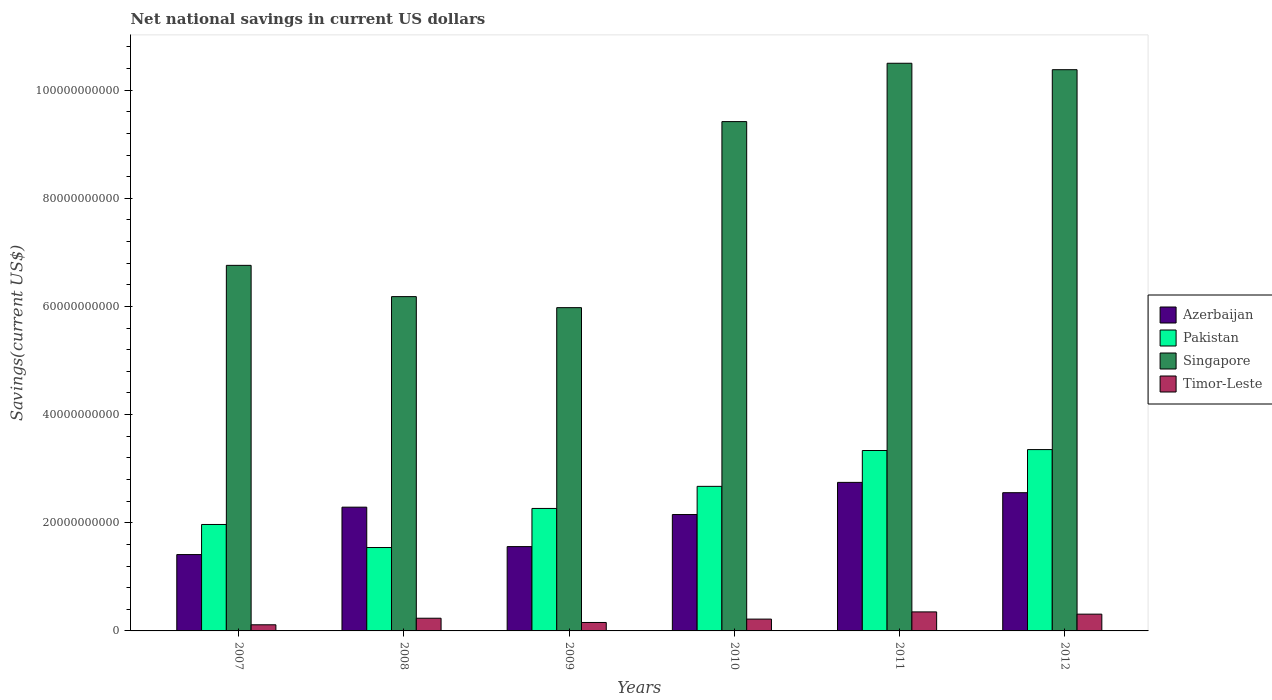Are the number of bars per tick equal to the number of legend labels?
Provide a succinct answer. Yes. Are the number of bars on each tick of the X-axis equal?
Your answer should be very brief. Yes. How many bars are there on the 1st tick from the right?
Your answer should be very brief. 4. In how many cases, is the number of bars for a given year not equal to the number of legend labels?
Your response must be concise. 0. What is the net national savings in Pakistan in 2009?
Your response must be concise. 2.26e+1. Across all years, what is the maximum net national savings in Pakistan?
Make the answer very short. 3.35e+1. Across all years, what is the minimum net national savings in Pakistan?
Offer a terse response. 1.54e+1. What is the total net national savings in Singapore in the graph?
Give a very brief answer. 4.92e+11. What is the difference between the net national savings in Singapore in 2009 and that in 2010?
Provide a short and direct response. -3.44e+1. What is the difference between the net national savings in Timor-Leste in 2011 and the net national savings in Azerbaijan in 2012?
Your answer should be very brief. -2.20e+1. What is the average net national savings in Pakistan per year?
Offer a very short reply. 2.52e+1. In the year 2011, what is the difference between the net national savings in Singapore and net national savings in Azerbaijan?
Provide a succinct answer. 7.75e+1. What is the ratio of the net national savings in Pakistan in 2009 to that in 2011?
Your answer should be very brief. 0.68. Is the difference between the net national savings in Singapore in 2009 and 2010 greater than the difference between the net national savings in Azerbaijan in 2009 and 2010?
Offer a very short reply. No. What is the difference between the highest and the second highest net national savings in Pakistan?
Ensure brevity in your answer.  1.69e+08. What is the difference between the highest and the lowest net national savings in Singapore?
Make the answer very short. 4.52e+1. In how many years, is the net national savings in Azerbaijan greater than the average net national savings in Azerbaijan taken over all years?
Provide a short and direct response. 4. Is the sum of the net national savings in Singapore in 2007 and 2010 greater than the maximum net national savings in Azerbaijan across all years?
Offer a terse response. Yes. Is it the case that in every year, the sum of the net national savings in Azerbaijan and net national savings in Singapore is greater than the sum of net national savings in Pakistan and net national savings in Timor-Leste?
Provide a short and direct response. Yes. What does the 2nd bar from the left in 2008 represents?
Make the answer very short. Pakistan. What does the 3rd bar from the right in 2012 represents?
Keep it short and to the point. Pakistan. Is it the case that in every year, the sum of the net national savings in Azerbaijan and net national savings in Pakistan is greater than the net national savings in Timor-Leste?
Make the answer very short. Yes. How many bars are there?
Offer a very short reply. 24. What is the difference between two consecutive major ticks on the Y-axis?
Offer a terse response. 2.00e+1. Are the values on the major ticks of Y-axis written in scientific E-notation?
Provide a succinct answer. No. Does the graph contain any zero values?
Ensure brevity in your answer.  No. How many legend labels are there?
Keep it short and to the point. 4. What is the title of the graph?
Ensure brevity in your answer.  Net national savings in current US dollars. What is the label or title of the X-axis?
Your answer should be compact. Years. What is the label or title of the Y-axis?
Keep it short and to the point. Savings(current US$). What is the Savings(current US$) in Azerbaijan in 2007?
Your answer should be very brief. 1.41e+1. What is the Savings(current US$) of Pakistan in 2007?
Give a very brief answer. 1.97e+1. What is the Savings(current US$) of Singapore in 2007?
Provide a succinct answer. 6.76e+1. What is the Savings(current US$) of Timor-Leste in 2007?
Your response must be concise. 1.13e+09. What is the Savings(current US$) in Azerbaijan in 2008?
Provide a short and direct response. 2.29e+1. What is the Savings(current US$) of Pakistan in 2008?
Your answer should be compact. 1.54e+1. What is the Savings(current US$) of Singapore in 2008?
Offer a very short reply. 6.18e+1. What is the Savings(current US$) in Timor-Leste in 2008?
Your response must be concise. 2.35e+09. What is the Savings(current US$) of Azerbaijan in 2009?
Provide a succinct answer. 1.56e+1. What is the Savings(current US$) of Pakistan in 2009?
Offer a very short reply. 2.26e+1. What is the Savings(current US$) in Singapore in 2009?
Your answer should be compact. 5.98e+1. What is the Savings(current US$) of Timor-Leste in 2009?
Make the answer very short. 1.56e+09. What is the Savings(current US$) of Azerbaijan in 2010?
Make the answer very short. 2.15e+1. What is the Savings(current US$) in Pakistan in 2010?
Your answer should be compact. 2.67e+1. What is the Savings(current US$) of Singapore in 2010?
Your answer should be compact. 9.42e+1. What is the Savings(current US$) of Timor-Leste in 2010?
Your response must be concise. 2.18e+09. What is the Savings(current US$) of Azerbaijan in 2011?
Your answer should be compact. 2.75e+1. What is the Savings(current US$) in Pakistan in 2011?
Give a very brief answer. 3.34e+1. What is the Savings(current US$) in Singapore in 2011?
Give a very brief answer. 1.05e+11. What is the Savings(current US$) of Timor-Leste in 2011?
Ensure brevity in your answer.  3.52e+09. What is the Savings(current US$) of Azerbaijan in 2012?
Offer a terse response. 2.56e+1. What is the Savings(current US$) of Pakistan in 2012?
Offer a very short reply. 3.35e+1. What is the Savings(current US$) of Singapore in 2012?
Offer a terse response. 1.04e+11. What is the Savings(current US$) of Timor-Leste in 2012?
Your response must be concise. 3.10e+09. Across all years, what is the maximum Savings(current US$) of Azerbaijan?
Your answer should be very brief. 2.75e+1. Across all years, what is the maximum Savings(current US$) in Pakistan?
Provide a short and direct response. 3.35e+1. Across all years, what is the maximum Savings(current US$) in Singapore?
Give a very brief answer. 1.05e+11. Across all years, what is the maximum Savings(current US$) in Timor-Leste?
Give a very brief answer. 3.52e+09. Across all years, what is the minimum Savings(current US$) in Azerbaijan?
Your answer should be compact. 1.41e+1. Across all years, what is the minimum Savings(current US$) in Pakistan?
Provide a succinct answer. 1.54e+1. Across all years, what is the minimum Savings(current US$) in Singapore?
Your response must be concise. 5.98e+1. Across all years, what is the minimum Savings(current US$) in Timor-Leste?
Give a very brief answer. 1.13e+09. What is the total Savings(current US$) in Azerbaijan in the graph?
Provide a succinct answer. 1.27e+11. What is the total Savings(current US$) of Pakistan in the graph?
Ensure brevity in your answer.  1.51e+11. What is the total Savings(current US$) of Singapore in the graph?
Provide a short and direct response. 4.92e+11. What is the total Savings(current US$) in Timor-Leste in the graph?
Keep it short and to the point. 1.38e+1. What is the difference between the Savings(current US$) of Azerbaijan in 2007 and that in 2008?
Your response must be concise. -8.77e+09. What is the difference between the Savings(current US$) in Pakistan in 2007 and that in 2008?
Make the answer very short. 4.26e+09. What is the difference between the Savings(current US$) in Singapore in 2007 and that in 2008?
Provide a short and direct response. 5.78e+09. What is the difference between the Savings(current US$) in Timor-Leste in 2007 and that in 2008?
Offer a terse response. -1.21e+09. What is the difference between the Savings(current US$) of Azerbaijan in 2007 and that in 2009?
Ensure brevity in your answer.  -1.47e+09. What is the difference between the Savings(current US$) of Pakistan in 2007 and that in 2009?
Your answer should be very brief. -2.97e+09. What is the difference between the Savings(current US$) of Singapore in 2007 and that in 2009?
Give a very brief answer. 7.82e+09. What is the difference between the Savings(current US$) of Timor-Leste in 2007 and that in 2009?
Your response must be concise. -4.27e+08. What is the difference between the Savings(current US$) in Azerbaijan in 2007 and that in 2010?
Make the answer very short. -7.40e+09. What is the difference between the Savings(current US$) in Pakistan in 2007 and that in 2010?
Keep it short and to the point. -7.05e+09. What is the difference between the Savings(current US$) in Singapore in 2007 and that in 2010?
Give a very brief answer. -2.66e+1. What is the difference between the Savings(current US$) in Timor-Leste in 2007 and that in 2010?
Your response must be concise. -1.05e+09. What is the difference between the Savings(current US$) of Azerbaijan in 2007 and that in 2011?
Offer a terse response. -1.33e+1. What is the difference between the Savings(current US$) of Pakistan in 2007 and that in 2011?
Your answer should be very brief. -1.37e+1. What is the difference between the Savings(current US$) in Singapore in 2007 and that in 2011?
Offer a very short reply. -3.74e+1. What is the difference between the Savings(current US$) in Timor-Leste in 2007 and that in 2011?
Provide a short and direct response. -2.38e+09. What is the difference between the Savings(current US$) in Azerbaijan in 2007 and that in 2012?
Make the answer very short. -1.14e+1. What is the difference between the Savings(current US$) of Pakistan in 2007 and that in 2012?
Your answer should be compact. -1.38e+1. What is the difference between the Savings(current US$) of Singapore in 2007 and that in 2012?
Ensure brevity in your answer.  -3.62e+1. What is the difference between the Savings(current US$) of Timor-Leste in 2007 and that in 2012?
Provide a succinct answer. -1.97e+09. What is the difference between the Savings(current US$) of Azerbaijan in 2008 and that in 2009?
Provide a succinct answer. 7.29e+09. What is the difference between the Savings(current US$) of Pakistan in 2008 and that in 2009?
Provide a short and direct response. -7.23e+09. What is the difference between the Savings(current US$) in Singapore in 2008 and that in 2009?
Provide a succinct answer. 2.04e+09. What is the difference between the Savings(current US$) in Timor-Leste in 2008 and that in 2009?
Your answer should be very brief. 7.85e+08. What is the difference between the Savings(current US$) in Azerbaijan in 2008 and that in 2010?
Keep it short and to the point. 1.36e+09. What is the difference between the Savings(current US$) in Pakistan in 2008 and that in 2010?
Provide a succinct answer. -1.13e+1. What is the difference between the Savings(current US$) of Singapore in 2008 and that in 2010?
Your answer should be very brief. -3.24e+1. What is the difference between the Savings(current US$) in Timor-Leste in 2008 and that in 2010?
Offer a terse response. 1.62e+08. What is the difference between the Savings(current US$) in Azerbaijan in 2008 and that in 2011?
Your answer should be very brief. -4.58e+09. What is the difference between the Savings(current US$) of Pakistan in 2008 and that in 2011?
Offer a very short reply. -1.79e+1. What is the difference between the Savings(current US$) of Singapore in 2008 and that in 2011?
Your answer should be very brief. -4.31e+1. What is the difference between the Savings(current US$) of Timor-Leste in 2008 and that in 2011?
Offer a very short reply. -1.17e+09. What is the difference between the Savings(current US$) of Azerbaijan in 2008 and that in 2012?
Offer a terse response. -2.68e+09. What is the difference between the Savings(current US$) of Pakistan in 2008 and that in 2012?
Provide a succinct answer. -1.81e+1. What is the difference between the Savings(current US$) of Singapore in 2008 and that in 2012?
Ensure brevity in your answer.  -4.20e+1. What is the difference between the Savings(current US$) in Timor-Leste in 2008 and that in 2012?
Provide a succinct answer. -7.54e+08. What is the difference between the Savings(current US$) of Azerbaijan in 2009 and that in 2010?
Your answer should be very brief. -5.93e+09. What is the difference between the Savings(current US$) in Pakistan in 2009 and that in 2010?
Offer a very short reply. -4.08e+09. What is the difference between the Savings(current US$) of Singapore in 2009 and that in 2010?
Offer a terse response. -3.44e+1. What is the difference between the Savings(current US$) in Timor-Leste in 2009 and that in 2010?
Keep it short and to the point. -6.23e+08. What is the difference between the Savings(current US$) in Azerbaijan in 2009 and that in 2011?
Your answer should be very brief. -1.19e+1. What is the difference between the Savings(current US$) of Pakistan in 2009 and that in 2011?
Give a very brief answer. -1.07e+1. What is the difference between the Savings(current US$) of Singapore in 2009 and that in 2011?
Ensure brevity in your answer.  -4.52e+1. What is the difference between the Savings(current US$) in Timor-Leste in 2009 and that in 2011?
Provide a short and direct response. -1.96e+09. What is the difference between the Savings(current US$) of Azerbaijan in 2009 and that in 2012?
Make the answer very short. -9.97e+09. What is the difference between the Savings(current US$) in Pakistan in 2009 and that in 2012?
Ensure brevity in your answer.  -1.09e+1. What is the difference between the Savings(current US$) in Singapore in 2009 and that in 2012?
Give a very brief answer. -4.40e+1. What is the difference between the Savings(current US$) of Timor-Leste in 2009 and that in 2012?
Keep it short and to the point. -1.54e+09. What is the difference between the Savings(current US$) of Azerbaijan in 2010 and that in 2011?
Offer a terse response. -5.95e+09. What is the difference between the Savings(current US$) of Pakistan in 2010 and that in 2011?
Offer a terse response. -6.63e+09. What is the difference between the Savings(current US$) of Singapore in 2010 and that in 2011?
Offer a terse response. -1.08e+1. What is the difference between the Savings(current US$) in Timor-Leste in 2010 and that in 2011?
Your answer should be very brief. -1.33e+09. What is the difference between the Savings(current US$) in Azerbaijan in 2010 and that in 2012?
Your answer should be compact. -4.04e+09. What is the difference between the Savings(current US$) in Pakistan in 2010 and that in 2012?
Give a very brief answer. -6.80e+09. What is the difference between the Savings(current US$) in Singapore in 2010 and that in 2012?
Give a very brief answer. -9.60e+09. What is the difference between the Savings(current US$) in Timor-Leste in 2010 and that in 2012?
Provide a short and direct response. -9.16e+08. What is the difference between the Savings(current US$) in Azerbaijan in 2011 and that in 2012?
Your answer should be very brief. 1.91e+09. What is the difference between the Savings(current US$) in Pakistan in 2011 and that in 2012?
Offer a very short reply. -1.69e+08. What is the difference between the Savings(current US$) in Singapore in 2011 and that in 2012?
Provide a succinct answer. 1.19e+09. What is the difference between the Savings(current US$) of Timor-Leste in 2011 and that in 2012?
Your answer should be compact. 4.17e+08. What is the difference between the Savings(current US$) of Azerbaijan in 2007 and the Savings(current US$) of Pakistan in 2008?
Ensure brevity in your answer.  -1.30e+09. What is the difference between the Savings(current US$) of Azerbaijan in 2007 and the Savings(current US$) of Singapore in 2008?
Your answer should be compact. -4.77e+1. What is the difference between the Savings(current US$) in Azerbaijan in 2007 and the Savings(current US$) in Timor-Leste in 2008?
Provide a succinct answer. 1.18e+1. What is the difference between the Savings(current US$) of Pakistan in 2007 and the Savings(current US$) of Singapore in 2008?
Make the answer very short. -4.21e+1. What is the difference between the Savings(current US$) in Pakistan in 2007 and the Savings(current US$) in Timor-Leste in 2008?
Provide a short and direct response. 1.73e+1. What is the difference between the Savings(current US$) of Singapore in 2007 and the Savings(current US$) of Timor-Leste in 2008?
Ensure brevity in your answer.  6.53e+1. What is the difference between the Savings(current US$) of Azerbaijan in 2007 and the Savings(current US$) of Pakistan in 2009?
Your response must be concise. -8.53e+09. What is the difference between the Savings(current US$) of Azerbaijan in 2007 and the Savings(current US$) of Singapore in 2009?
Keep it short and to the point. -4.57e+1. What is the difference between the Savings(current US$) of Azerbaijan in 2007 and the Savings(current US$) of Timor-Leste in 2009?
Offer a terse response. 1.26e+1. What is the difference between the Savings(current US$) in Pakistan in 2007 and the Savings(current US$) in Singapore in 2009?
Give a very brief answer. -4.01e+1. What is the difference between the Savings(current US$) in Pakistan in 2007 and the Savings(current US$) in Timor-Leste in 2009?
Provide a short and direct response. 1.81e+1. What is the difference between the Savings(current US$) in Singapore in 2007 and the Savings(current US$) in Timor-Leste in 2009?
Provide a short and direct response. 6.60e+1. What is the difference between the Savings(current US$) of Azerbaijan in 2007 and the Savings(current US$) of Pakistan in 2010?
Provide a short and direct response. -1.26e+1. What is the difference between the Savings(current US$) in Azerbaijan in 2007 and the Savings(current US$) in Singapore in 2010?
Make the answer very short. -8.01e+1. What is the difference between the Savings(current US$) in Azerbaijan in 2007 and the Savings(current US$) in Timor-Leste in 2010?
Your response must be concise. 1.19e+1. What is the difference between the Savings(current US$) in Pakistan in 2007 and the Savings(current US$) in Singapore in 2010?
Provide a succinct answer. -7.45e+1. What is the difference between the Savings(current US$) of Pakistan in 2007 and the Savings(current US$) of Timor-Leste in 2010?
Offer a very short reply. 1.75e+1. What is the difference between the Savings(current US$) in Singapore in 2007 and the Savings(current US$) in Timor-Leste in 2010?
Keep it short and to the point. 6.54e+1. What is the difference between the Savings(current US$) of Azerbaijan in 2007 and the Savings(current US$) of Pakistan in 2011?
Your response must be concise. -1.92e+1. What is the difference between the Savings(current US$) of Azerbaijan in 2007 and the Savings(current US$) of Singapore in 2011?
Offer a terse response. -9.08e+1. What is the difference between the Savings(current US$) in Azerbaijan in 2007 and the Savings(current US$) in Timor-Leste in 2011?
Offer a very short reply. 1.06e+1. What is the difference between the Savings(current US$) in Pakistan in 2007 and the Savings(current US$) in Singapore in 2011?
Your answer should be very brief. -8.53e+1. What is the difference between the Savings(current US$) of Pakistan in 2007 and the Savings(current US$) of Timor-Leste in 2011?
Keep it short and to the point. 1.62e+1. What is the difference between the Savings(current US$) in Singapore in 2007 and the Savings(current US$) in Timor-Leste in 2011?
Ensure brevity in your answer.  6.41e+1. What is the difference between the Savings(current US$) of Azerbaijan in 2007 and the Savings(current US$) of Pakistan in 2012?
Give a very brief answer. -1.94e+1. What is the difference between the Savings(current US$) in Azerbaijan in 2007 and the Savings(current US$) in Singapore in 2012?
Offer a terse response. -8.97e+1. What is the difference between the Savings(current US$) in Azerbaijan in 2007 and the Savings(current US$) in Timor-Leste in 2012?
Keep it short and to the point. 1.10e+1. What is the difference between the Savings(current US$) in Pakistan in 2007 and the Savings(current US$) in Singapore in 2012?
Your answer should be very brief. -8.41e+1. What is the difference between the Savings(current US$) of Pakistan in 2007 and the Savings(current US$) of Timor-Leste in 2012?
Ensure brevity in your answer.  1.66e+1. What is the difference between the Savings(current US$) in Singapore in 2007 and the Savings(current US$) in Timor-Leste in 2012?
Provide a short and direct response. 6.45e+1. What is the difference between the Savings(current US$) of Azerbaijan in 2008 and the Savings(current US$) of Pakistan in 2009?
Ensure brevity in your answer.  2.37e+08. What is the difference between the Savings(current US$) of Azerbaijan in 2008 and the Savings(current US$) of Singapore in 2009?
Provide a succinct answer. -3.69e+1. What is the difference between the Savings(current US$) of Azerbaijan in 2008 and the Savings(current US$) of Timor-Leste in 2009?
Keep it short and to the point. 2.13e+1. What is the difference between the Savings(current US$) in Pakistan in 2008 and the Savings(current US$) in Singapore in 2009?
Provide a short and direct response. -4.44e+1. What is the difference between the Savings(current US$) of Pakistan in 2008 and the Savings(current US$) of Timor-Leste in 2009?
Your answer should be very brief. 1.39e+1. What is the difference between the Savings(current US$) in Singapore in 2008 and the Savings(current US$) in Timor-Leste in 2009?
Keep it short and to the point. 6.03e+1. What is the difference between the Savings(current US$) of Azerbaijan in 2008 and the Savings(current US$) of Pakistan in 2010?
Your answer should be compact. -3.85e+09. What is the difference between the Savings(current US$) of Azerbaijan in 2008 and the Savings(current US$) of Singapore in 2010?
Make the answer very short. -7.13e+1. What is the difference between the Savings(current US$) in Azerbaijan in 2008 and the Savings(current US$) in Timor-Leste in 2010?
Your answer should be very brief. 2.07e+1. What is the difference between the Savings(current US$) in Pakistan in 2008 and the Savings(current US$) in Singapore in 2010?
Offer a terse response. -7.88e+1. What is the difference between the Savings(current US$) in Pakistan in 2008 and the Savings(current US$) in Timor-Leste in 2010?
Your answer should be compact. 1.32e+1. What is the difference between the Savings(current US$) of Singapore in 2008 and the Savings(current US$) of Timor-Leste in 2010?
Your answer should be very brief. 5.96e+1. What is the difference between the Savings(current US$) of Azerbaijan in 2008 and the Savings(current US$) of Pakistan in 2011?
Offer a very short reply. -1.05e+1. What is the difference between the Savings(current US$) of Azerbaijan in 2008 and the Savings(current US$) of Singapore in 2011?
Provide a succinct answer. -8.21e+1. What is the difference between the Savings(current US$) in Azerbaijan in 2008 and the Savings(current US$) in Timor-Leste in 2011?
Ensure brevity in your answer.  1.94e+1. What is the difference between the Savings(current US$) in Pakistan in 2008 and the Savings(current US$) in Singapore in 2011?
Your answer should be very brief. -8.95e+1. What is the difference between the Savings(current US$) in Pakistan in 2008 and the Savings(current US$) in Timor-Leste in 2011?
Provide a short and direct response. 1.19e+1. What is the difference between the Savings(current US$) of Singapore in 2008 and the Savings(current US$) of Timor-Leste in 2011?
Keep it short and to the point. 5.83e+1. What is the difference between the Savings(current US$) in Azerbaijan in 2008 and the Savings(current US$) in Pakistan in 2012?
Provide a succinct answer. -1.06e+1. What is the difference between the Savings(current US$) of Azerbaijan in 2008 and the Savings(current US$) of Singapore in 2012?
Offer a terse response. -8.09e+1. What is the difference between the Savings(current US$) of Azerbaijan in 2008 and the Savings(current US$) of Timor-Leste in 2012?
Your answer should be very brief. 1.98e+1. What is the difference between the Savings(current US$) of Pakistan in 2008 and the Savings(current US$) of Singapore in 2012?
Ensure brevity in your answer.  -8.84e+1. What is the difference between the Savings(current US$) in Pakistan in 2008 and the Savings(current US$) in Timor-Leste in 2012?
Your response must be concise. 1.23e+1. What is the difference between the Savings(current US$) in Singapore in 2008 and the Savings(current US$) in Timor-Leste in 2012?
Make the answer very short. 5.87e+1. What is the difference between the Savings(current US$) in Azerbaijan in 2009 and the Savings(current US$) in Pakistan in 2010?
Ensure brevity in your answer.  -1.11e+1. What is the difference between the Savings(current US$) of Azerbaijan in 2009 and the Savings(current US$) of Singapore in 2010?
Provide a succinct answer. -7.86e+1. What is the difference between the Savings(current US$) of Azerbaijan in 2009 and the Savings(current US$) of Timor-Leste in 2010?
Keep it short and to the point. 1.34e+1. What is the difference between the Savings(current US$) of Pakistan in 2009 and the Savings(current US$) of Singapore in 2010?
Keep it short and to the point. -7.15e+1. What is the difference between the Savings(current US$) in Pakistan in 2009 and the Savings(current US$) in Timor-Leste in 2010?
Your answer should be very brief. 2.05e+1. What is the difference between the Savings(current US$) in Singapore in 2009 and the Savings(current US$) in Timor-Leste in 2010?
Keep it short and to the point. 5.76e+1. What is the difference between the Savings(current US$) in Azerbaijan in 2009 and the Savings(current US$) in Pakistan in 2011?
Make the answer very short. -1.78e+1. What is the difference between the Savings(current US$) of Azerbaijan in 2009 and the Savings(current US$) of Singapore in 2011?
Provide a short and direct response. -8.94e+1. What is the difference between the Savings(current US$) of Azerbaijan in 2009 and the Savings(current US$) of Timor-Leste in 2011?
Offer a very short reply. 1.21e+1. What is the difference between the Savings(current US$) of Pakistan in 2009 and the Savings(current US$) of Singapore in 2011?
Ensure brevity in your answer.  -8.23e+1. What is the difference between the Savings(current US$) in Pakistan in 2009 and the Savings(current US$) in Timor-Leste in 2011?
Ensure brevity in your answer.  1.91e+1. What is the difference between the Savings(current US$) in Singapore in 2009 and the Savings(current US$) in Timor-Leste in 2011?
Make the answer very short. 5.63e+1. What is the difference between the Savings(current US$) in Azerbaijan in 2009 and the Savings(current US$) in Pakistan in 2012?
Offer a very short reply. -1.79e+1. What is the difference between the Savings(current US$) of Azerbaijan in 2009 and the Savings(current US$) of Singapore in 2012?
Your answer should be very brief. -8.82e+1. What is the difference between the Savings(current US$) of Azerbaijan in 2009 and the Savings(current US$) of Timor-Leste in 2012?
Make the answer very short. 1.25e+1. What is the difference between the Savings(current US$) in Pakistan in 2009 and the Savings(current US$) in Singapore in 2012?
Make the answer very short. -8.11e+1. What is the difference between the Savings(current US$) of Pakistan in 2009 and the Savings(current US$) of Timor-Leste in 2012?
Offer a terse response. 1.95e+1. What is the difference between the Savings(current US$) of Singapore in 2009 and the Savings(current US$) of Timor-Leste in 2012?
Your answer should be very brief. 5.67e+1. What is the difference between the Savings(current US$) in Azerbaijan in 2010 and the Savings(current US$) in Pakistan in 2011?
Your answer should be compact. -1.18e+1. What is the difference between the Savings(current US$) of Azerbaijan in 2010 and the Savings(current US$) of Singapore in 2011?
Your response must be concise. -8.34e+1. What is the difference between the Savings(current US$) in Azerbaijan in 2010 and the Savings(current US$) in Timor-Leste in 2011?
Provide a short and direct response. 1.80e+1. What is the difference between the Savings(current US$) of Pakistan in 2010 and the Savings(current US$) of Singapore in 2011?
Ensure brevity in your answer.  -7.82e+1. What is the difference between the Savings(current US$) of Pakistan in 2010 and the Savings(current US$) of Timor-Leste in 2011?
Your response must be concise. 2.32e+1. What is the difference between the Savings(current US$) of Singapore in 2010 and the Savings(current US$) of Timor-Leste in 2011?
Give a very brief answer. 9.07e+1. What is the difference between the Savings(current US$) of Azerbaijan in 2010 and the Savings(current US$) of Pakistan in 2012?
Provide a succinct answer. -1.20e+1. What is the difference between the Savings(current US$) of Azerbaijan in 2010 and the Savings(current US$) of Singapore in 2012?
Your answer should be compact. -8.23e+1. What is the difference between the Savings(current US$) in Azerbaijan in 2010 and the Savings(current US$) in Timor-Leste in 2012?
Your answer should be compact. 1.84e+1. What is the difference between the Savings(current US$) of Pakistan in 2010 and the Savings(current US$) of Singapore in 2012?
Provide a succinct answer. -7.70e+1. What is the difference between the Savings(current US$) of Pakistan in 2010 and the Savings(current US$) of Timor-Leste in 2012?
Your answer should be compact. 2.36e+1. What is the difference between the Savings(current US$) in Singapore in 2010 and the Savings(current US$) in Timor-Leste in 2012?
Provide a succinct answer. 9.11e+1. What is the difference between the Savings(current US$) of Azerbaijan in 2011 and the Savings(current US$) of Pakistan in 2012?
Provide a short and direct response. -6.06e+09. What is the difference between the Savings(current US$) of Azerbaijan in 2011 and the Savings(current US$) of Singapore in 2012?
Your answer should be compact. -7.63e+1. What is the difference between the Savings(current US$) in Azerbaijan in 2011 and the Savings(current US$) in Timor-Leste in 2012?
Keep it short and to the point. 2.44e+1. What is the difference between the Savings(current US$) of Pakistan in 2011 and the Savings(current US$) of Singapore in 2012?
Ensure brevity in your answer.  -7.04e+1. What is the difference between the Savings(current US$) of Pakistan in 2011 and the Savings(current US$) of Timor-Leste in 2012?
Your answer should be compact. 3.03e+1. What is the difference between the Savings(current US$) in Singapore in 2011 and the Savings(current US$) in Timor-Leste in 2012?
Offer a very short reply. 1.02e+11. What is the average Savings(current US$) in Azerbaijan per year?
Your response must be concise. 2.12e+1. What is the average Savings(current US$) in Pakistan per year?
Your answer should be compact. 2.52e+1. What is the average Savings(current US$) in Singapore per year?
Your answer should be compact. 8.20e+1. What is the average Savings(current US$) of Timor-Leste per year?
Offer a very short reply. 2.31e+09. In the year 2007, what is the difference between the Savings(current US$) in Azerbaijan and Savings(current US$) in Pakistan?
Offer a terse response. -5.56e+09. In the year 2007, what is the difference between the Savings(current US$) in Azerbaijan and Savings(current US$) in Singapore?
Provide a succinct answer. -5.35e+1. In the year 2007, what is the difference between the Savings(current US$) in Azerbaijan and Savings(current US$) in Timor-Leste?
Your response must be concise. 1.30e+1. In the year 2007, what is the difference between the Savings(current US$) of Pakistan and Savings(current US$) of Singapore?
Your response must be concise. -4.79e+1. In the year 2007, what is the difference between the Savings(current US$) in Pakistan and Savings(current US$) in Timor-Leste?
Give a very brief answer. 1.85e+1. In the year 2007, what is the difference between the Savings(current US$) of Singapore and Savings(current US$) of Timor-Leste?
Your answer should be very brief. 6.65e+1. In the year 2008, what is the difference between the Savings(current US$) of Azerbaijan and Savings(current US$) of Pakistan?
Ensure brevity in your answer.  7.46e+09. In the year 2008, what is the difference between the Savings(current US$) of Azerbaijan and Savings(current US$) of Singapore?
Ensure brevity in your answer.  -3.89e+1. In the year 2008, what is the difference between the Savings(current US$) in Azerbaijan and Savings(current US$) in Timor-Leste?
Give a very brief answer. 2.05e+1. In the year 2008, what is the difference between the Savings(current US$) of Pakistan and Savings(current US$) of Singapore?
Your answer should be compact. -4.64e+1. In the year 2008, what is the difference between the Savings(current US$) in Pakistan and Savings(current US$) in Timor-Leste?
Give a very brief answer. 1.31e+1. In the year 2008, what is the difference between the Savings(current US$) in Singapore and Savings(current US$) in Timor-Leste?
Your answer should be compact. 5.95e+1. In the year 2009, what is the difference between the Savings(current US$) of Azerbaijan and Savings(current US$) of Pakistan?
Offer a very short reply. -7.06e+09. In the year 2009, what is the difference between the Savings(current US$) of Azerbaijan and Savings(current US$) of Singapore?
Provide a short and direct response. -4.42e+1. In the year 2009, what is the difference between the Savings(current US$) in Azerbaijan and Savings(current US$) in Timor-Leste?
Your answer should be compact. 1.40e+1. In the year 2009, what is the difference between the Savings(current US$) in Pakistan and Savings(current US$) in Singapore?
Offer a very short reply. -3.71e+1. In the year 2009, what is the difference between the Savings(current US$) of Pakistan and Savings(current US$) of Timor-Leste?
Give a very brief answer. 2.11e+1. In the year 2009, what is the difference between the Savings(current US$) of Singapore and Savings(current US$) of Timor-Leste?
Provide a short and direct response. 5.82e+1. In the year 2010, what is the difference between the Savings(current US$) in Azerbaijan and Savings(current US$) in Pakistan?
Your answer should be very brief. -5.21e+09. In the year 2010, what is the difference between the Savings(current US$) in Azerbaijan and Savings(current US$) in Singapore?
Ensure brevity in your answer.  -7.27e+1. In the year 2010, what is the difference between the Savings(current US$) of Azerbaijan and Savings(current US$) of Timor-Leste?
Ensure brevity in your answer.  1.93e+1. In the year 2010, what is the difference between the Savings(current US$) of Pakistan and Savings(current US$) of Singapore?
Offer a terse response. -6.74e+1. In the year 2010, what is the difference between the Savings(current US$) in Pakistan and Savings(current US$) in Timor-Leste?
Offer a terse response. 2.45e+1. In the year 2010, what is the difference between the Savings(current US$) of Singapore and Savings(current US$) of Timor-Leste?
Your answer should be compact. 9.20e+1. In the year 2011, what is the difference between the Savings(current US$) of Azerbaijan and Savings(current US$) of Pakistan?
Your answer should be compact. -5.89e+09. In the year 2011, what is the difference between the Savings(current US$) in Azerbaijan and Savings(current US$) in Singapore?
Your response must be concise. -7.75e+1. In the year 2011, what is the difference between the Savings(current US$) of Azerbaijan and Savings(current US$) of Timor-Leste?
Your answer should be very brief. 2.39e+1. In the year 2011, what is the difference between the Savings(current US$) of Pakistan and Savings(current US$) of Singapore?
Offer a terse response. -7.16e+1. In the year 2011, what is the difference between the Savings(current US$) in Pakistan and Savings(current US$) in Timor-Leste?
Your response must be concise. 2.98e+1. In the year 2011, what is the difference between the Savings(current US$) in Singapore and Savings(current US$) in Timor-Leste?
Give a very brief answer. 1.01e+11. In the year 2012, what is the difference between the Savings(current US$) in Azerbaijan and Savings(current US$) in Pakistan?
Your response must be concise. -7.97e+09. In the year 2012, what is the difference between the Savings(current US$) of Azerbaijan and Savings(current US$) of Singapore?
Offer a terse response. -7.82e+1. In the year 2012, what is the difference between the Savings(current US$) in Azerbaijan and Savings(current US$) in Timor-Leste?
Make the answer very short. 2.25e+1. In the year 2012, what is the difference between the Savings(current US$) in Pakistan and Savings(current US$) in Singapore?
Offer a very short reply. -7.02e+1. In the year 2012, what is the difference between the Savings(current US$) in Pakistan and Savings(current US$) in Timor-Leste?
Make the answer very short. 3.04e+1. In the year 2012, what is the difference between the Savings(current US$) of Singapore and Savings(current US$) of Timor-Leste?
Give a very brief answer. 1.01e+11. What is the ratio of the Savings(current US$) in Azerbaijan in 2007 to that in 2008?
Your answer should be very brief. 0.62. What is the ratio of the Savings(current US$) of Pakistan in 2007 to that in 2008?
Provide a succinct answer. 1.28. What is the ratio of the Savings(current US$) in Singapore in 2007 to that in 2008?
Your response must be concise. 1.09. What is the ratio of the Savings(current US$) of Timor-Leste in 2007 to that in 2008?
Keep it short and to the point. 0.48. What is the ratio of the Savings(current US$) of Azerbaijan in 2007 to that in 2009?
Your answer should be very brief. 0.91. What is the ratio of the Savings(current US$) in Pakistan in 2007 to that in 2009?
Your answer should be very brief. 0.87. What is the ratio of the Savings(current US$) in Singapore in 2007 to that in 2009?
Your answer should be compact. 1.13. What is the ratio of the Savings(current US$) of Timor-Leste in 2007 to that in 2009?
Ensure brevity in your answer.  0.73. What is the ratio of the Savings(current US$) of Azerbaijan in 2007 to that in 2010?
Provide a short and direct response. 0.66. What is the ratio of the Savings(current US$) of Pakistan in 2007 to that in 2010?
Offer a terse response. 0.74. What is the ratio of the Savings(current US$) of Singapore in 2007 to that in 2010?
Your answer should be compact. 0.72. What is the ratio of the Savings(current US$) of Timor-Leste in 2007 to that in 2010?
Keep it short and to the point. 0.52. What is the ratio of the Savings(current US$) in Azerbaijan in 2007 to that in 2011?
Your answer should be very brief. 0.51. What is the ratio of the Savings(current US$) in Pakistan in 2007 to that in 2011?
Offer a very short reply. 0.59. What is the ratio of the Savings(current US$) of Singapore in 2007 to that in 2011?
Ensure brevity in your answer.  0.64. What is the ratio of the Savings(current US$) in Timor-Leste in 2007 to that in 2011?
Make the answer very short. 0.32. What is the ratio of the Savings(current US$) in Azerbaijan in 2007 to that in 2012?
Ensure brevity in your answer.  0.55. What is the ratio of the Savings(current US$) of Pakistan in 2007 to that in 2012?
Offer a very short reply. 0.59. What is the ratio of the Savings(current US$) of Singapore in 2007 to that in 2012?
Keep it short and to the point. 0.65. What is the ratio of the Savings(current US$) of Timor-Leste in 2007 to that in 2012?
Give a very brief answer. 0.37. What is the ratio of the Savings(current US$) of Azerbaijan in 2008 to that in 2009?
Keep it short and to the point. 1.47. What is the ratio of the Savings(current US$) in Pakistan in 2008 to that in 2009?
Ensure brevity in your answer.  0.68. What is the ratio of the Savings(current US$) in Singapore in 2008 to that in 2009?
Offer a very short reply. 1.03. What is the ratio of the Savings(current US$) of Timor-Leste in 2008 to that in 2009?
Ensure brevity in your answer.  1.5. What is the ratio of the Savings(current US$) in Azerbaijan in 2008 to that in 2010?
Ensure brevity in your answer.  1.06. What is the ratio of the Savings(current US$) in Pakistan in 2008 to that in 2010?
Your answer should be very brief. 0.58. What is the ratio of the Savings(current US$) in Singapore in 2008 to that in 2010?
Make the answer very short. 0.66. What is the ratio of the Savings(current US$) in Timor-Leste in 2008 to that in 2010?
Your answer should be very brief. 1.07. What is the ratio of the Savings(current US$) in Azerbaijan in 2008 to that in 2011?
Provide a short and direct response. 0.83. What is the ratio of the Savings(current US$) of Pakistan in 2008 to that in 2011?
Ensure brevity in your answer.  0.46. What is the ratio of the Savings(current US$) in Singapore in 2008 to that in 2011?
Make the answer very short. 0.59. What is the ratio of the Savings(current US$) in Timor-Leste in 2008 to that in 2011?
Ensure brevity in your answer.  0.67. What is the ratio of the Savings(current US$) in Azerbaijan in 2008 to that in 2012?
Provide a short and direct response. 0.9. What is the ratio of the Savings(current US$) in Pakistan in 2008 to that in 2012?
Ensure brevity in your answer.  0.46. What is the ratio of the Savings(current US$) in Singapore in 2008 to that in 2012?
Offer a terse response. 0.6. What is the ratio of the Savings(current US$) in Timor-Leste in 2008 to that in 2012?
Provide a short and direct response. 0.76. What is the ratio of the Savings(current US$) of Azerbaijan in 2009 to that in 2010?
Your answer should be very brief. 0.72. What is the ratio of the Savings(current US$) of Pakistan in 2009 to that in 2010?
Your response must be concise. 0.85. What is the ratio of the Savings(current US$) of Singapore in 2009 to that in 2010?
Make the answer very short. 0.63. What is the ratio of the Savings(current US$) in Timor-Leste in 2009 to that in 2010?
Your answer should be very brief. 0.71. What is the ratio of the Savings(current US$) of Azerbaijan in 2009 to that in 2011?
Your answer should be very brief. 0.57. What is the ratio of the Savings(current US$) of Pakistan in 2009 to that in 2011?
Your response must be concise. 0.68. What is the ratio of the Savings(current US$) of Singapore in 2009 to that in 2011?
Your answer should be compact. 0.57. What is the ratio of the Savings(current US$) in Timor-Leste in 2009 to that in 2011?
Provide a succinct answer. 0.44. What is the ratio of the Savings(current US$) in Azerbaijan in 2009 to that in 2012?
Keep it short and to the point. 0.61. What is the ratio of the Savings(current US$) in Pakistan in 2009 to that in 2012?
Offer a terse response. 0.68. What is the ratio of the Savings(current US$) of Singapore in 2009 to that in 2012?
Ensure brevity in your answer.  0.58. What is the ratio of the Savings(current US$) of Timor-Leste in 2009 to that in 2012?
Keep it short and to the point. 0.5. What is the ratio of the Savings(current US$) of Azerbaijan in 2010 to that in 2011?
Your answer should be very brief. 0.78. What is the ratio of the Savings(current US$) in Pakistan in 2010 to that in 2011?
Your answer should be very brief. 0.8. What is the ratio of the Savings(current US$) in Singapore in 2010 to that in 2011?
Your response must be concise. 0.9. What is the ratio of the Savings(current US$) of Timor-Leste in 2010 to that in 2011?
Your answer should be compact. 0.62. What is the ratio of the Savings(current US$) of Azerbaijan in 2010 to that in 2012?
Offer a very short reply. 0.84. What is the ratio of the Savings(current US$) of Pakistan in 2010 to that in 2012?
Your response must be concise. 0.8. What is the ratio of the Savings(current US$) in Singapore in 2010 to that in 2012?
Provide a short and direct response. 0.91. What is the ratio of the Savings(current US$) in Timor-Leste in 2010 to that in 2012?
Give a very brief answer. 0.7. What is the ratio of the Savings(current US$) of Azerbaijan in 2011 to that in 2012?
Provide a succinct answer. 1.07. What is the ratio of the Savings(current US$) of Pakistan in 2011 to that in 2012?
Your response must be concise. 0.99. What is the ratio of the Savings(current US$) of Singapore in 2011 to that in 2012?
Provide a succinct answer. 1.01. What is the ratio of the Savings(current US$) of Timor-Leste in 2011 to that in 2012?
Keep it short and to the point. 1.13. What is the difference between the highest and the second highest Savings(current US$) in Azerbaijan?
Make the answer very short. 1.91e+09. What is the difference between the highest and the second highest Savings(current US$) in Pakistan?
Give a very brief answer. 1.69e+08. What is the difference between the highest and the second highest Savings(current US$) in Singapore?
Provide a short and direct response. 1.19e+09. What is the difference between the highest and the second highest Savings(current US$) of Timor-Leste?
Provide a succinct answer. 4.17e+08. What is the difference between the highest and the lowest Savings(current US$) of Azerbaijan?
Offer a very short reply. 1.33e+1. What is the difference between the highest and the lowest Savings(current US$) of Pakistan?
Make the answer very short. 1.81e+1. What is the difference between the highest and the lowest Savings(current US$) of Singapore?
Provide a succinct answer. 4.52e+1. What is the difference between the highest and the lowest Savings(current US$) of Timor-Leste?
Provide a succinct answer. 2.38e+09. 